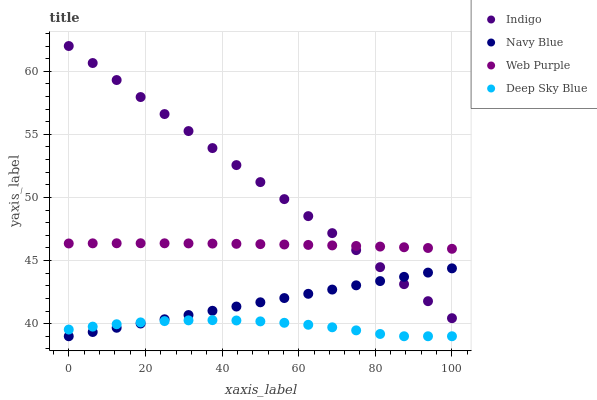Does Deep Sky Blue have the minimum area under the curve?
Answer yes or no. Yes. Does Indigo have the maximum area under the curve?
Answer yes or no. Yes. Does Web Purple have the minimum area under the curve?
Answer yes or no. No. Does Web Purple have the maximum area under the curve?
Answer yes or no. No. Is Indigo the smoothest?
Answer yes or no. Yes. Is Deep Sky Blue the roughest?
Answer yes or no. Yes. Is Web Purple the smoothest?
Answer yes or no. No. Is Web Purple the roughest?
Answer yes or no. No. Does Navy Blue have the lowest value?
Answer yes or no. Yes. Does Indigo have the lowest value?
Answer yes or no. No. Does Indigo have the highest value?
Answer yes or no. Yes. Does Web Purple have the highest value?
Answer yes or no. No. Is Deep Sky Blue less than Web Purple?
Answer yes or no. Yes. Is Web Purple greater than Deep Sky Blue?
Answer yes or no. Yes. Does Web Purple intersect Indigo?
Answer yes or no. Yes. Is Web Purple less than Indigo?
Answer yes or no. No. Is Web Purple greater than Indigo?
Answer yes or no. No. Does Deep Sky Blue intersect Web Purple?
Answer yes or no. No. 